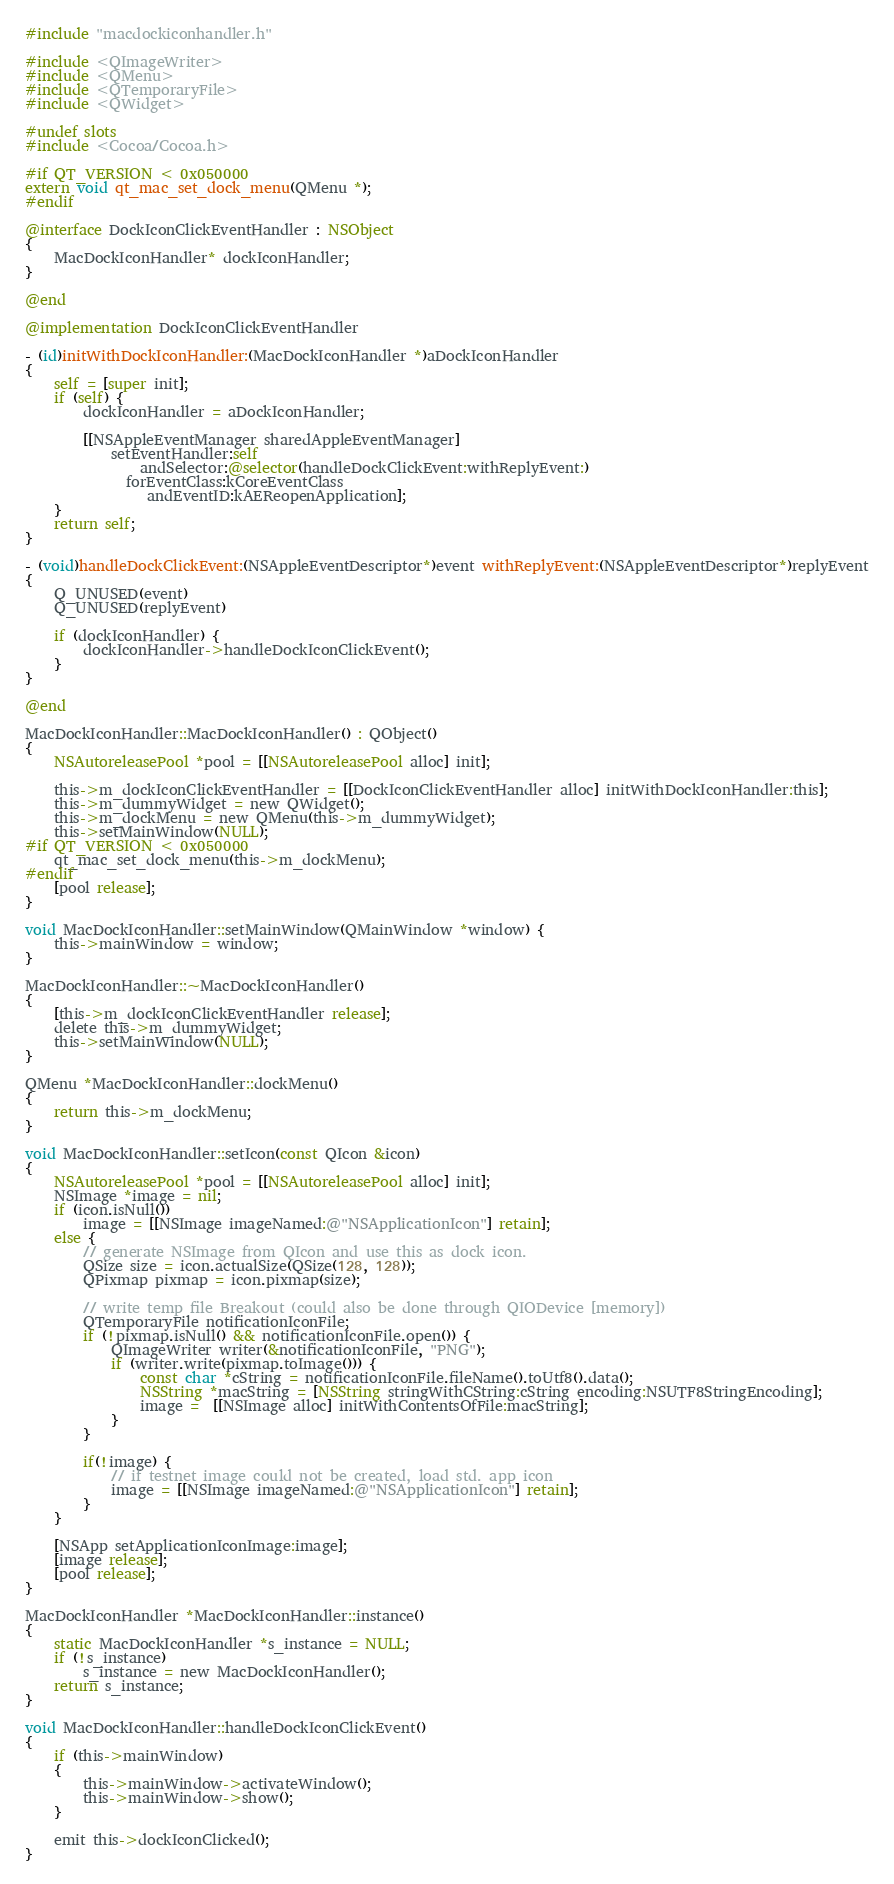<code> <loc_0><loc_0><loc_500><loc_500><_ObjectiveC_>#include "macdockiconhandler.h"

#include <QImageWriter>
#include <QMenu>
#include <QTemporaryFile>
#include <QWidget>

#undef slots
#include <Cocoa/Cocoa.h>

#if QT_VERSION < 0x050000
extern void qt_mac_set_dock_menu(QMenu *);
#endif

@interface DockIconClickEventHandler : NSObject
{
    MacDockIconHandler* dockIconHandler;
}

@end

@implementation DockIconClickEventHandler

- (id)initWithDockIconHandler:(MacDockIconHandler *)aDockIconHandler
{
    self = [super init];
    if (self) {
        dockIconHandler = aDockIconHandler;

        [[NSAppleEventManager sharedAppleEventManager]
            setEventHandler:self
                andSelector:@selector(handleDockClickEvent:withReplyEvent:)
              forEventClass:kCoreEventClass
                 andEventID:kAEReopenApplication];
    }
    return self;
}

- (void)handleDockClickEvent:(NSAppleEventDescriptor*)event withReplyEvent:(NSAppleEventDescriptor*)replyEvent
{
    Q_UNUSED(event)
    Q_UNUSED(replyEvent)

    if (dockIconHandler) {
        dockIconHandler->handleDockIconClickEvent();
    }
}

@end

MacDockIconHandler::MacDockIconHandler() : QObject()
{
    NSAutoreleasePool *pool = [[NSAutoreleasePool alloc] init];

    this->m_dockIconClickEventHandler = [[DockIconClickEventHandler alloc] initWithDockIconHandler:this];
    this->m_dummyWidget = new QWidget();
    this->m_dockMenu = new QMenu(this->m_dummyWidget);
    this->setMainWindow(NULL);
#if QT_VERSION < 0x050000
    qt_mac_set_dock_menu(this->m_dockMenu);
#endif
    [pool release];
}

void MacDockIconHandler::setMainWindow(QMainWindow *window) {
    this->mainWindow = window;
}

MacDockIconHandler::~MacDockIconHandler()
{
    [this->m_dockIconClickEventHandler release];
    delete this->m_dummyWidget;
    this->setMainWindow(NULL);
}

QMenu *MacDockIconHandler::dockMenu()
{
    return this->m_dockMenu;
}

void MacDockIconHandler::setIcon(const QIcon &icon)
{
    NSAutoreleasePool *pool = [[NSAutoreleasePool alloc] init];
    NSImage *image = nil;
    if (icon.isNull())
        image = [[NSImage imageNamed:@"NSApplicationIcon"] retain];
    else {
        // generate NSImage from QIcon and use this as dock icon.
        QSize size = icon.actualSize(QSize(128, 128));
        QPixmap pixmap = icon.pixmap(size);

        // write temp file Breakout (could also be done through QIODevice [memory])
        QTemporaryFile notificationIconFile;
        if (!pixmap.isNull() && notificationIconFile.open()) {
            QImageWriter writer(&notificationIconFile, "PNG");
            if (writer.write(pixmap.toImage())) {
                const char *cString = notificationIconFile.fileName().toUtf8().data();
                NSString *macString = [NSString stringWithCString:cString encoding:NSUTF8StringEncoding];
                image =  [[NSImage alloc] initWithContentsOfFile:macString];
            }
        }

        if(!image) {
            // if testnet image could not be created, load std. app icon
            image = [[NSImage imageNamed:@"NSApplicationIcon"] retain];
        }
    }

    [NSApp setApplicationIconImage:image];
    [image release];
    [pool release];
}

MacDockIconHandler *MacDockIconHandler::instance()
{
    static MacDockIconHandler *s_instance = NULL;
    if (!s_instance)
        s_instance = new MacDockIconHandler();
    return s_instance;
}

void MacDockIconHandler::handleDockIconClickEvent()
{
    if (this->mainWindow)
    {
        this->mainWindow->activateWindow();
        this->mainWindow->show();
    }

    emit this->dockIconClicked();
}
</code> 